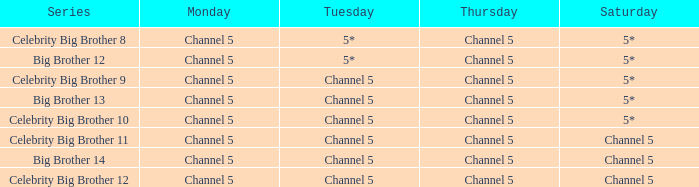On which thursday is big brother 13 aired? Channel 5. 